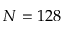<formula> <loc_0><loc_0><loc_500><loc_500>N = 1 2 8</formula> 